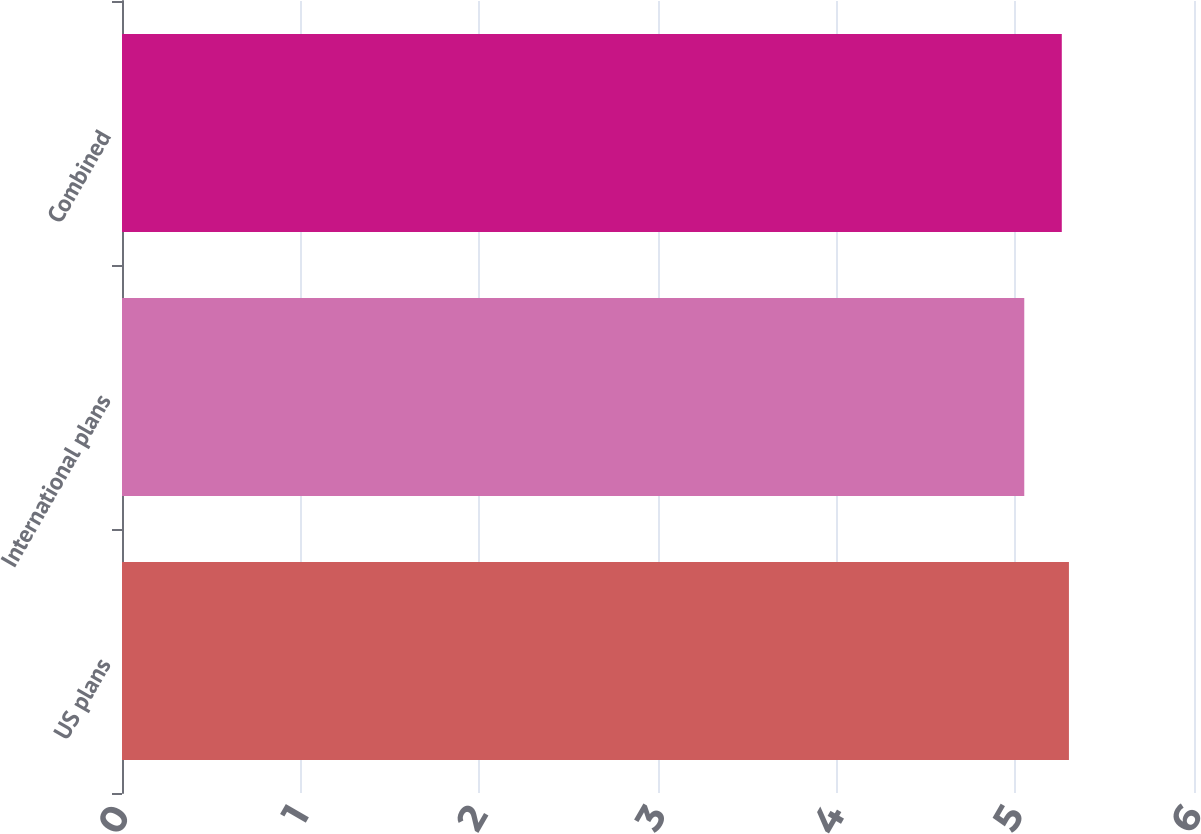Convert chart. <chart><loc_0><loc_0><loc_500><loc_500><bar_chart><fcel>US plans<fcel>International plans<fcel>Combined<nl><fcel>5.3<fcel>5.05<fcel>5.26<nl></chart> 